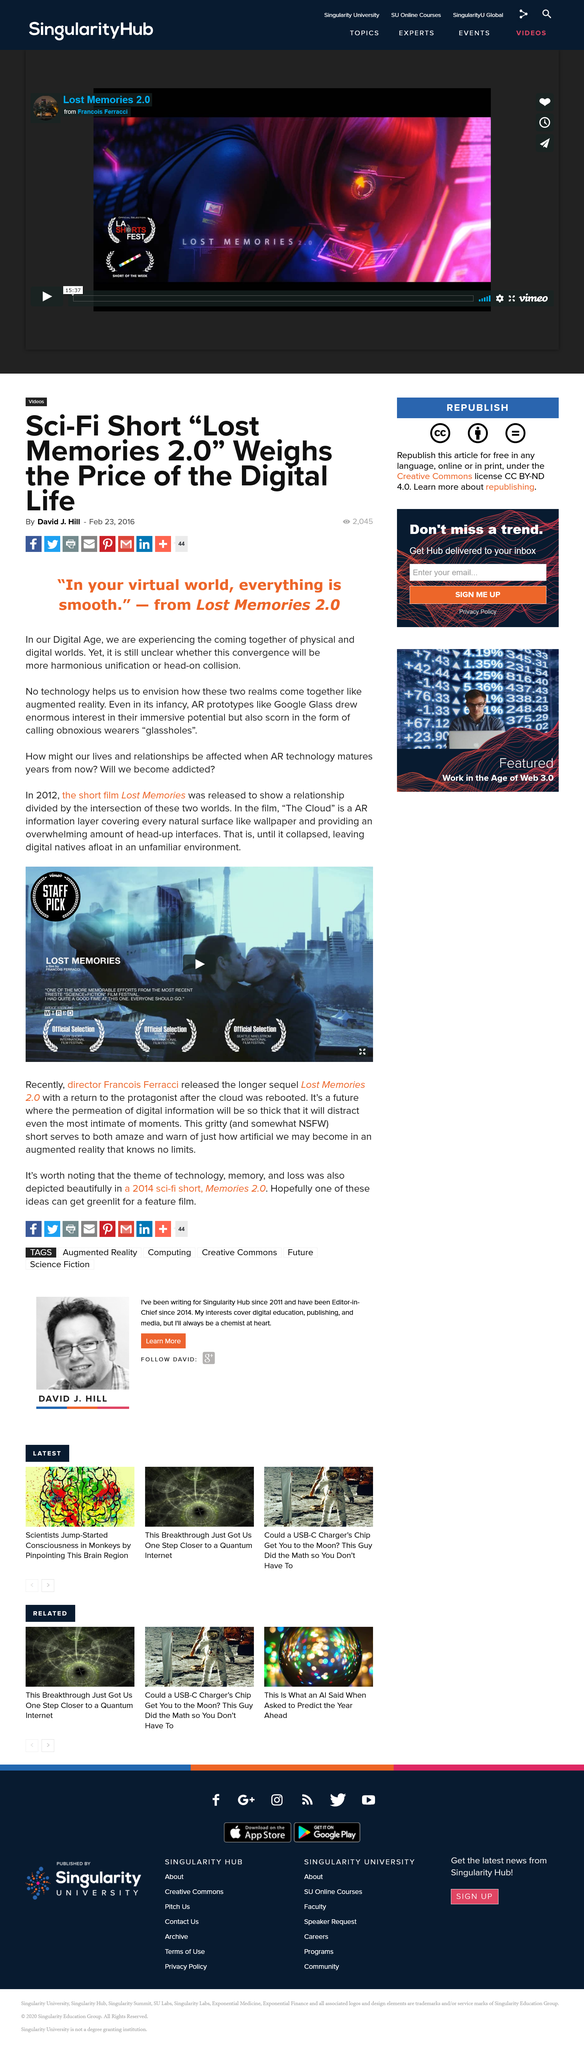Indicate a few pertinent items in this graphic. The article entitled "Sci-Fi Short “Lost Memories 2.0” Weighs the Price of the Digital Life?" was written by David J. Hill, who wrote the article about the sci-fi short that considers the cost of digital life. An AR prototype is an example of a type of augmented reality technology, specifically the Google Glass device. The quote "In your virtual world, everything is smooth" originates from Lost Memories 2.0. 